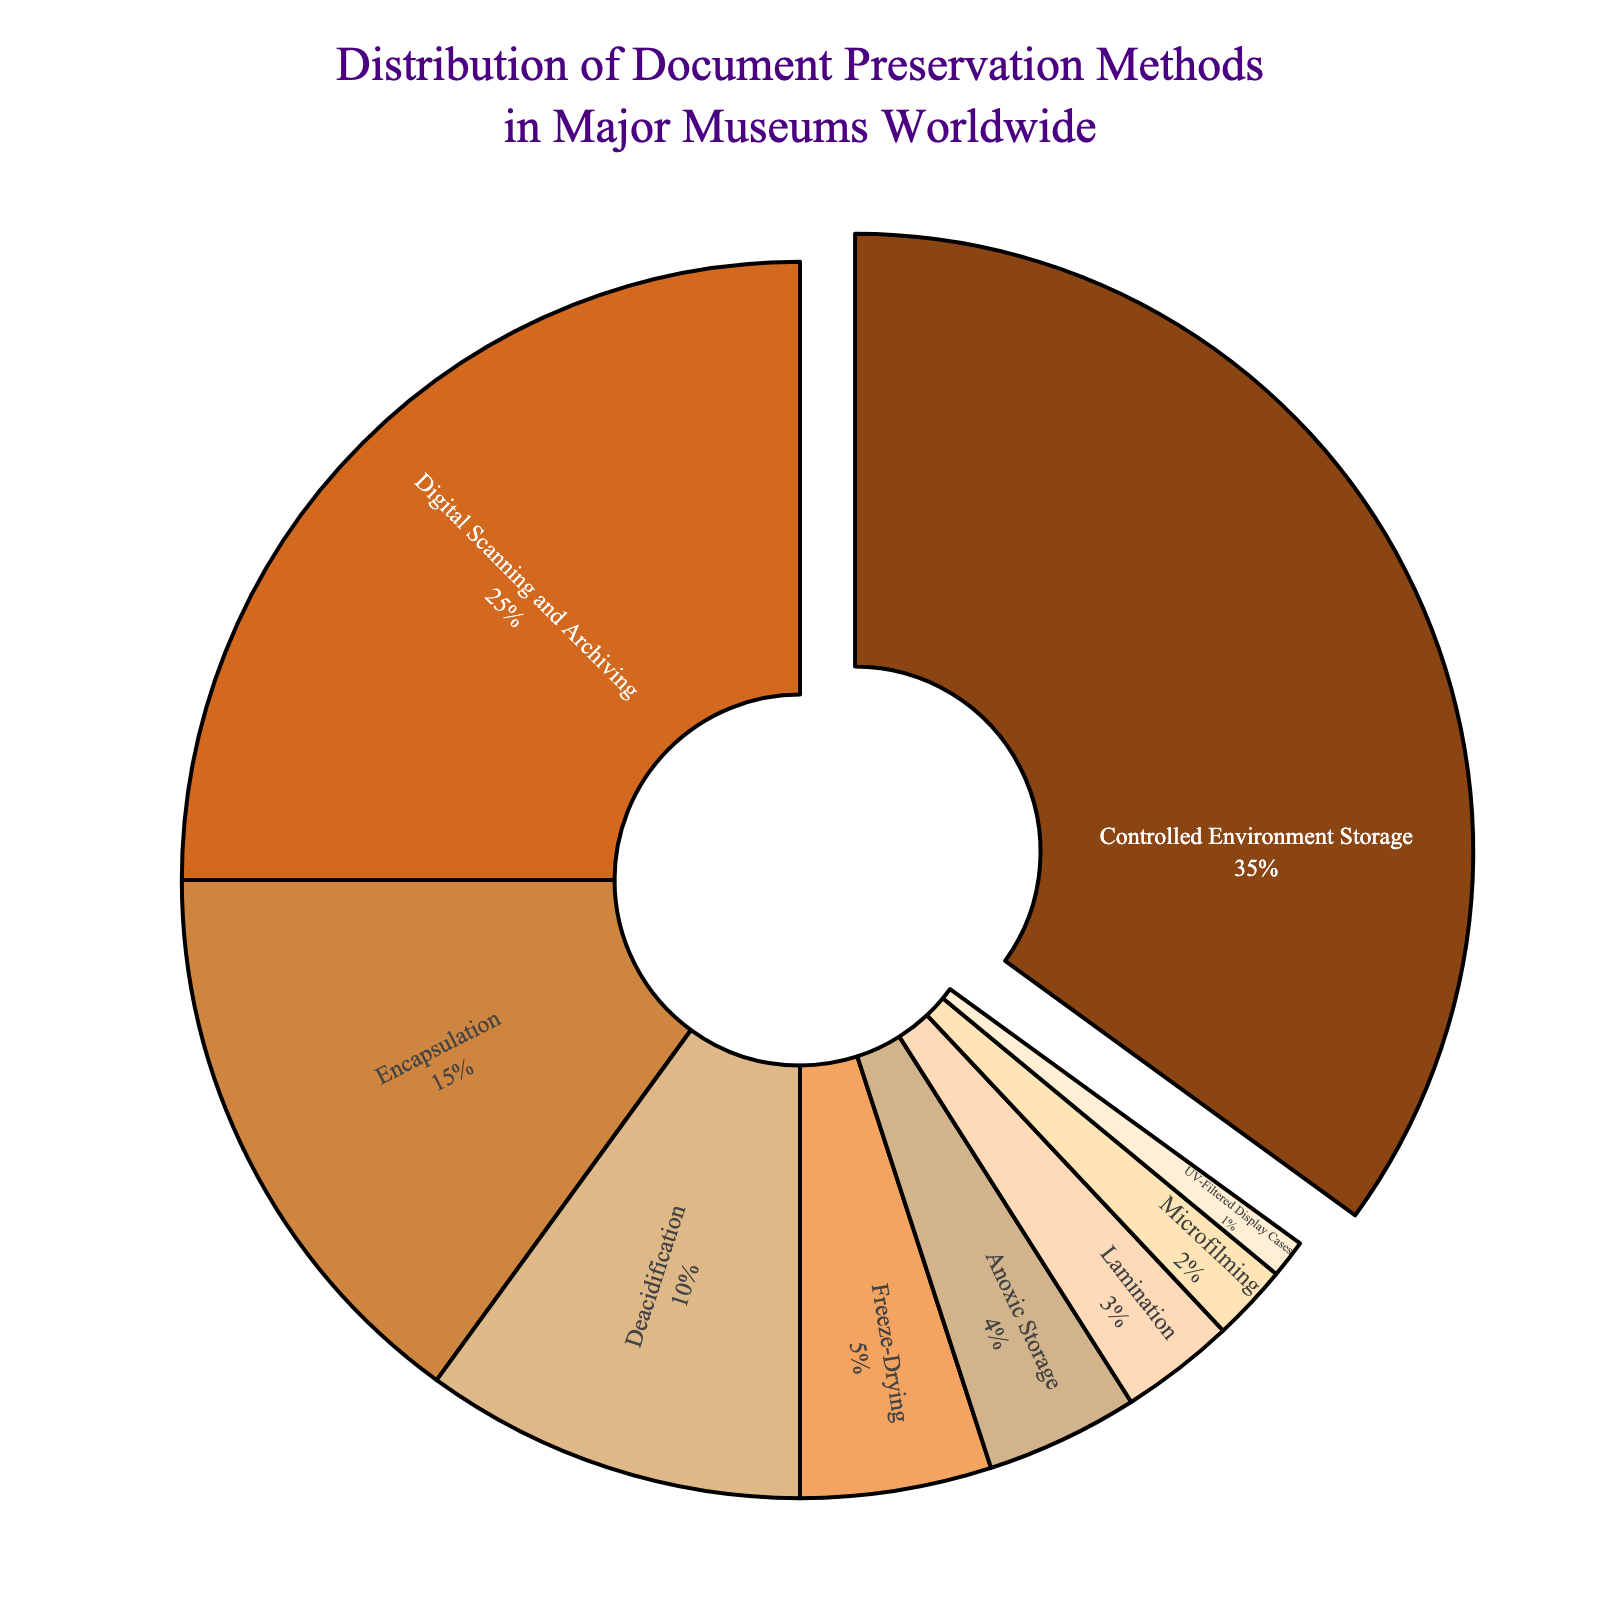What percentage of document preservation methods is accounted for by Controlled Environment Storage and Digital Scanning and Archiving combined? To determine the combined percentage, add the percentages of Controlled Environment Storage (35%) and Digital Scanning and Archiving (25%). Thus, the combined percentage is 35% + 25% = 60%
Answer: 60% Which document preservation method has the smallest percentage share? By analyzing the percentages in the chart, UV-Filtered Display Cases has the smallest share at 1%.
Answer: UV-Filtered Display Cases Which preservation methods together account for more than 50% of the total? Examining the figures, Controlled Environment Storage (35%) and Digital Scanning and Archiving (25%) together account for 35% + 25% = 60%, more than 50%. These two methods together exceed 50%.
Answer: Controlled Environment Storage and Digital Scanning and Archiving How does the percentage for Encapsulation compare to that of Deacidification? By looking at the percentages, Encapsulation has 15% while Deacidification has 10%. Encapsulation's percentage is greater than that of Deacidification by 15% - 10% = 5%.
Answer: Encapsulation is greater by 5% What is the difference in percentage between Lamination and Microfilming? Lamination has a percentage of 3% and Microfilming has 2%. The difference is 3% - 2% = 1%.
Answer: 1% What is the total percentage for the three preservation methods with the smallest shares? Adding the percentages of the smallest three: UV-Filtered Display Cases (1%), Microfilming (2%), and Lamination (3%), get 1% + 2% + 3% = 6%.
Answer: 6% Which preservation method is represented by the largest segment in the chart? The largest segment is Controlled Environment Storage, which represents 35% of the total methods.
Answer: Controlled Environment Storage Is the share of Digital Scanning and Archiving larger or smaller than the combined share of Freeze-Drying and Anoxic Storage? Digital Scanning and Archiving is 25%, while Freeze-Drying is 5% and Anoxic Storage is 4%. Combined is 5% + 4% = 9%. 25% is larger than 9%.
Answer: Larger What preservation methods' segments are shaded with more earthy tones, such as brown and tan? From the color scheme and the chart, Controlled Environment Storage, Digital Scanning and Archiving, Encapsulation, and Deacidification have earthy tones like brown and tan.
Answer: Controlled Environment Storage, Digital Scanning and Archiving, Encapsulation, Deacidification 